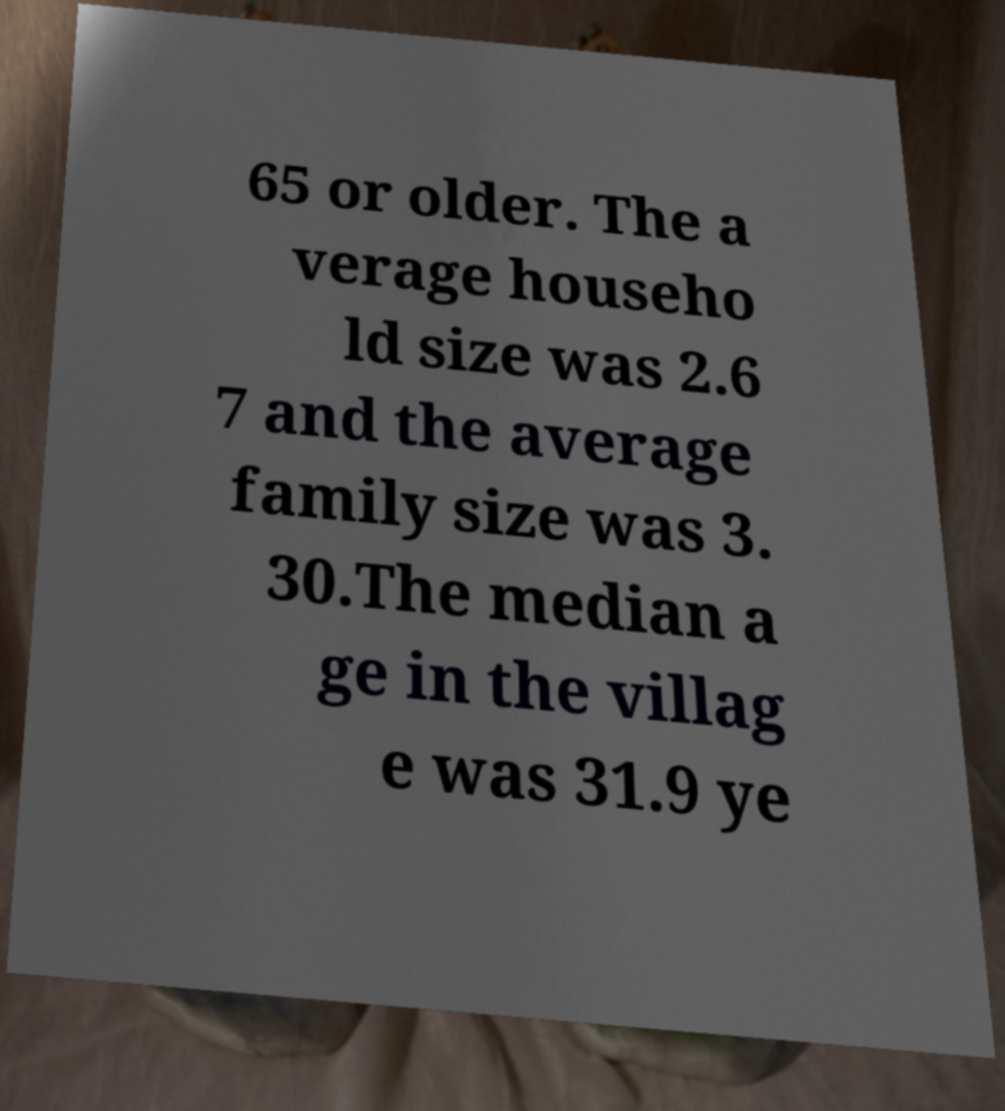Can you read and provide the text displayed in the image?This photo seems to have some interesting text. Can you extract and type it out for me? 65 or older. The a verage househo ld size was 2.6 7 and the average family size was 3. 30.The median a ge in the villag e was 31.9 ye 